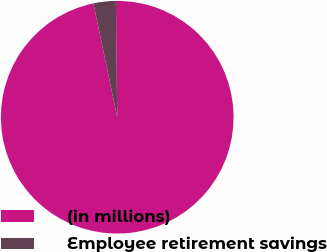Convert chart. <chart><loc_0><loc_0><loc_500><loc_500><pie_chart><fcel>(in millions)<fcel>Employee retirement savings<nl><fcel>96.9%<fcel>3.1%<nl></chart> 